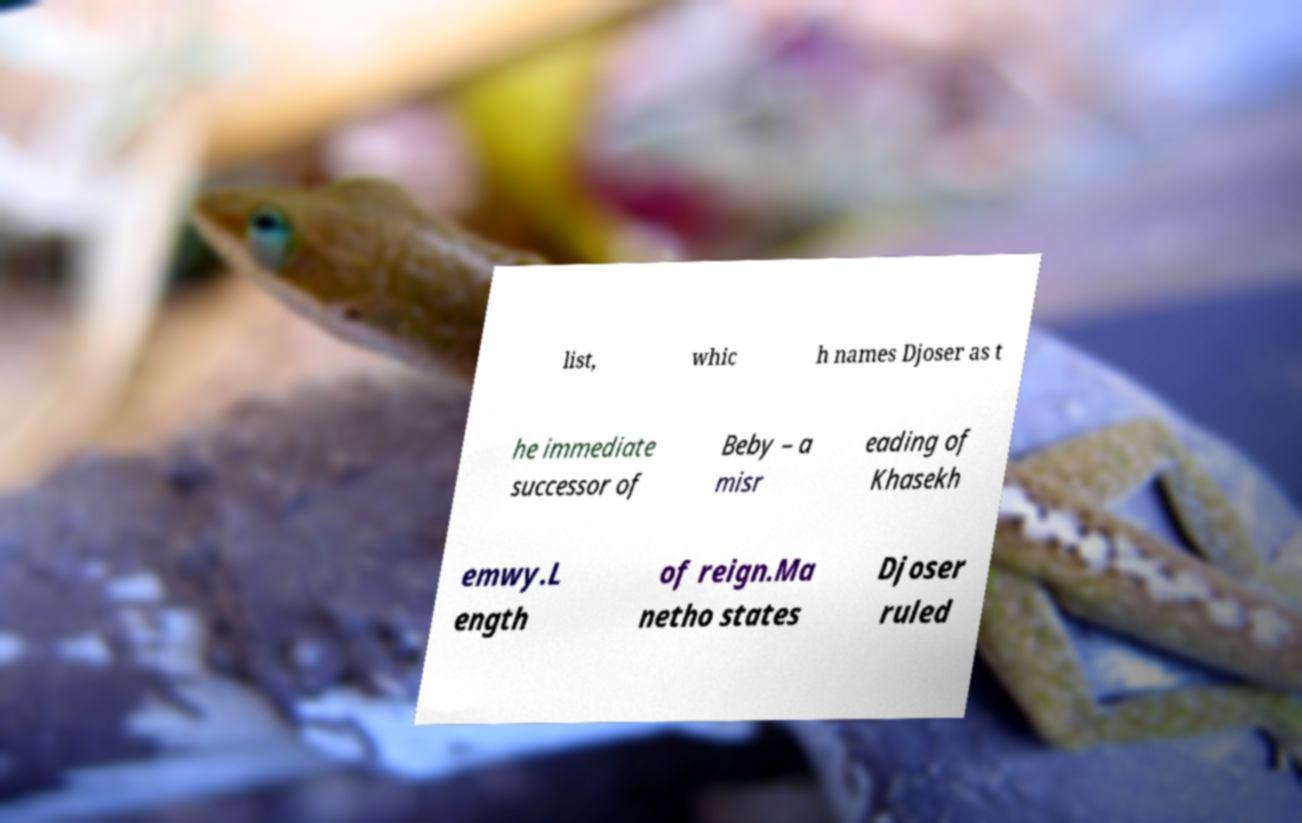Can you read and provide the text displayed in the image?This photo seems to have some interesting text. Can you extract and type it out for me? list, whic h names Djoser as t he immediate successor of Beby – a misr eading of Khasekh emwy.L ength of reign.Ma netho states Djoser ruled 